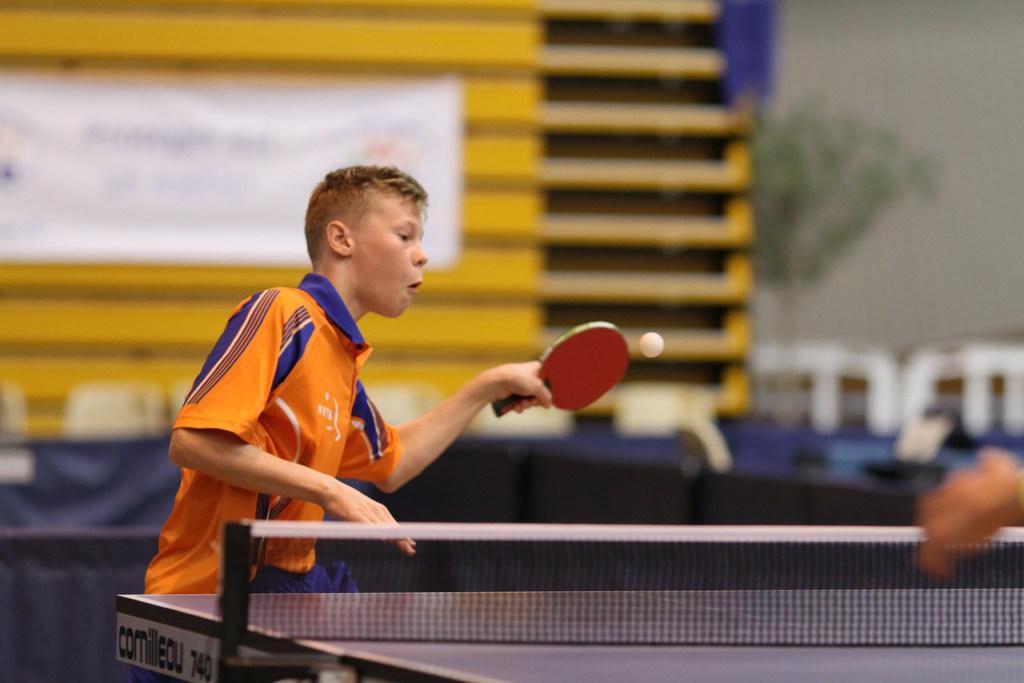Please provide a concise description of this image. This image is clicked in a table tennis court. There is a table tennis bat in his hand. There is a ball. There is a person standing near the table. He is wearing orange color dress. There is a net in the bottom. 